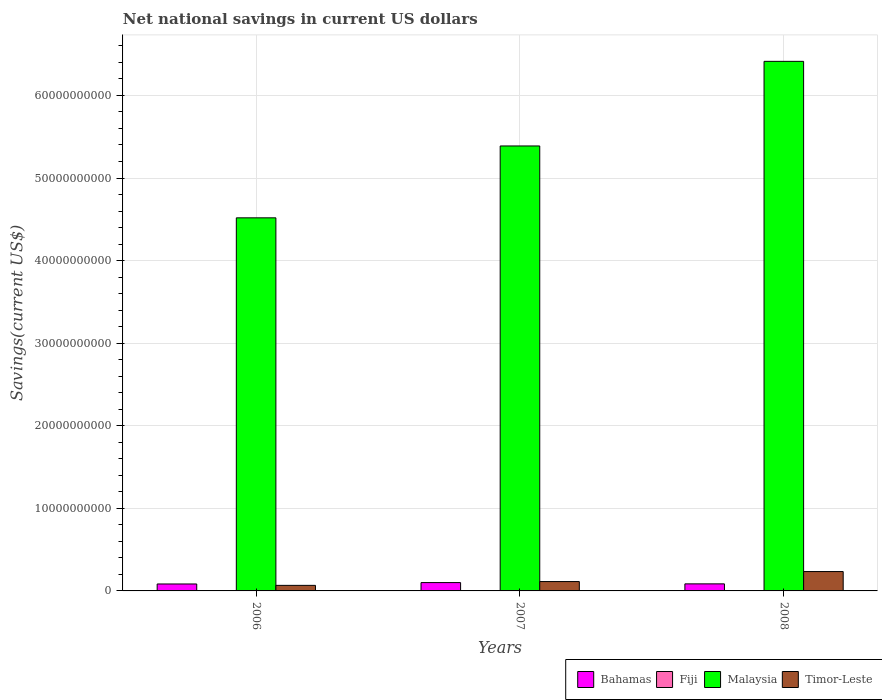How many different coloured bars are there?
Make the answer very short. 4. How many bars are there on the 2nd tick from the left?
Your answer should be very brief. 4. In how many cases, is the number of bars for a given year not equal to the number of legend labels?
Provide a succinct answer. 2. What is the net national savings in Bahamas in 2008?
Provide a short and direct response. 8.55e+08. Across all years, what is the maximum net national savings in Bahamas?
Provide a succinct answer. 1.01e+09. Across all years, what is the minimum net national savings in Timor-Leste?
Make the answer very short. 6.72e+08. What is the total net national savings in Bahamas in the graph?
Keep it short and to the point. 2.71e+09. What is the difference between the net national savings in Bahamas in 2006 and that in 2007?
Your response must be concise. -1.69e+08. What is the difference between the net national savings in Timor-Leste in 2007 and the net national savings in Malaysia in 2006?
Your answer should be very brief. -4.40e+1. What is the average net national savings in Timor-Leste per year?
Make the answer very short. 1.38e+09. In the year 2006, what is the difference between the net national savings in Timor-Leste and net national savings in Bahamas?
Offer a terse response. -1.70e+08. In how many years, is the net national savings in Bahamas greater than 24000000000 US$?
Offer a very short reply. 0. What is the ratio of the net national savings in Timor-Leste in 2006 to that in 2008?
Offer a very short reply. 0.29. Is the net national savings in Bahamas in 2006 less than that in 2007?
Ensure brevity in your answer.  Yes. What is the difference between the highest and the second highest net national savings in Timor-Leste?
Your answer should be very brief. 1.21e+09. What is the difference between the highest and the lowest net national savings in Bahamas?
Ensure brevity in your answer.  1.69e+08. Is the sum of the net national savings in Timor-Leste in 2006 and 2007 greater than the maximum net national savings in Malaysia across all years?
Offer a very short reply. No. Is it the case that in every year, the sum of the net national savings in Timor-Leste and net national savings in Malaysia is greater than the net national savings in Fiji?
Your answer should be compact. Yes. Are all the bars in the graph horizontal?
Keep it short and to the point. No. What is the difference between two consecutive major ticks on the Y-axis?
Offer a terse response. 1.00e+1. Are the values on the major ticks of Y-axis written in scientific E-notation?
Give a very brief answer. No. Where does the legend appear in the graph?
Your answer should be compact. Bottom right. What is the title of the graph?
Offer a terse response. Net national savings in current US dollars. What is the label or title of the Y-axis?
Give a very brief answer. Savings(current US$). What is the Savings(current US$) in Bahamas in 2006?
Make the answer very short. 8.41e+08. What is the Savings(current US$) in Malaysia in 2006?
Ensure brevity in your answer.  4.52e+1. What is the Savings(current US$) in Timor-Leste in 2006?
Your response must be concise. 6.72e+08. What is the Savings(current US$) in Bahamas in 2007?
Give a very brief answer. 1.01e+09. What is the Savings(current US$) of Fiji in 2007?
Make the answer very short. 1.97e+07. What is the Savings(current US$) of Malaysia in 2007?
Keep it short and to the point. 5.39e+1. What is the Savings(current US$) in Timor-Leste in 2007?
Give a very brief answer. 1.13e+09. What is the Savings(current US$) in Bahamas in 2008?
Offer a very short reply. 8.55e+08. What is the Savings(current US$) in Fiji in 2008?
Offer a terse response. 0. What is the Savings(current US$) of Malaysia in 2008?
Make the answer very short. 6.41e+1. What is the Savings(current US$) of Timor-Leste in 2008?
Provide a short and direct response. 2.35e+09. Across all years, what is the maximum Savings(current US$) of Bahamas?
Offer a terse response. 1.01e+09. Across all years, what is the maximum Savings(current US$) of Fiji?
Offer a terse response. 1.97e+07. Across all years, what is the maximum Savings(current US$) in Malaysia?
Keep it short and to the point. 6.41e+1. Across all years, what is the maximum Savings(current US$) of Timor-Leste?
Ensure brevity in your answer.  2.35e+09. Across all years, what is the minimum Savings(current US$) in Bahamas?
Provide a short and direct response. 8.41e+08. Across all years, what is the minimum Savings(current US$) in Malaysia?
Provide a succinct answer. 4.52e+1. Across all years, what is the minimum Savings(current US$) in Timor-Leste?
Provide a short and direct response. 6.72e+08. What is the total Savings(current US$) in Bahamas in the graph?
Ensure brevity in your answer.  2.71e+09. What is the total Savings(current US$) of Fiji in the graph?
Offer a terse response. 1.97e+07. What is the total Savings(current US$) in Malaysia in the graph?
Offer a very short reply. 1.63e+11. What is the total Savings(current US$) in Timor-Leste in the graph?
Provide a succinct answer. 4.15e+09. What is the difference between the Savings(current US$) in Bahamas in 2006 and that in 2007?
Your answer should be compact. -1.69e+08. What is the difference between the Savings(current US$) in Malaysia in 2006 and that in 2007?
Ensure brevity in your answer.  -8.70e+09. What is the difference between the Savings(current US$) in Timor-Leste in 2006 and that in 2007?
Offer a terse response. -4.62e+08. What is the difference between the Savings(current US$) in Bahamas in 2006 and that in 2008?
Offer a very short reply. -1.35e+07. What is the difference between the Savings(current US$) in Malaysia in 2006 and that in 2008?
Give a very brief answer. -1.89e+1. What is the difference between the Savings(current US$) of Timor-Leste in 2006 and that in 2008?
Provide a short and direct response. -1.67e+09. What is the difference between the Savings(current US$) of Bahamas in 2007 and that in 2008?
Your answer should be compact. 1.55e+08. What is the difference between the Savings(current US$) of Malaysia in 2007 and that in 2008?
Your answer should be compact. -1.02e+1. What is the difference between the Savings(current US$) of Timor-Leste in 2007 and that in 2008?
Your answer should be compact. -1.21e+09. What is the difference between the Savings(current US$) of Bahamas in 2006 and the Savings(current US$) of Fiji in 2007?
Keep it short and to the point. 8.22e+08. What is the difference between the Savings(current US$) in Bahamas in 2006 and the Savings(current US$) in Malaysia in 2007?
Offer a very short reply. -5.30e+1. What is the difference between the Savings(current US$) of Bahamas in 2006 and the Savings(current US$) of Timor-Leste in 2007?
Provide a succinct answer. -2.92e+08. What is the difference between the Savings(current US$) in Malaysia in 2006 and the Savings(current US$) in Timor-Leste in 2007?
Ensure brevity in your answer.  4.40e+1. What is the difference between the Savings(current US$) in Bahamas in 2006 and the Savings(current US$) in Malaysia in 2008?
Offer a very short reply. -6.33e+1. What is the difference between the Savings(current US$) of Bahamas in 2006 and the Savings(current US$) of Timor-Leste in 2008?
Offer a terse response. -1.50e+09. What is the difference between the Savings(current US$) in Malaysia in 2006 and the Savings(current US$) in Timor-Leste in 2008?
Make the answer very short. 4.28e+1. What is the difference between the Savings(current US$) of Bahamas in 2007 and the Savings(current US$) of Malaysia in 2008?
Provide a succinct answer. -6.31e+1. What is the difference between the Savings(current US$) of Bahamas in 2007 and the Savings(current US$) of Timor-Leste in 2008?
Make the answer very short. -1.34e+09. What is the difference between the Savings(current US$) of Fiji in 2007 and the Savings(current US$) of Malaysia in 2008?
Offer a terse response. -6.41e+1. What is the difference between the Savings(current US$) in Fiji in 2007 and the Savings(current US$) in Timor-Leste in 2008?
Your answer should be compact. -2.33e+09. What is the difference between the Savings(current US$) of Malaysia in 2007 and the Savings(current US$) of Timor-Leste in 2008?
Ensure brevity in your answer.  5.15e+1. What is the average Savings(current US$) in Bahamas per year?
Give a very brief answer. 9.02e+08. What is the average Savings(current US$) of Fiji per year?
Provide a succinct answer. 6.57e+06. What is the average Savings(current US$) of Malaysia per year?
Your response must be concise. 5.44e+1. What is the average Savings(current US$) in Timor-Leste per year?
Your answer should be very brief. 1.38e+09. In the year 2006, what is the difference between the Savings(current US$) in Bahamas and Savings(current US$) in Malaysia?
Offer a very short reply. -4.43e+1. In the year 2006, what is the difference between the Savings(current US$) in Bahamas and Savings(current US$) in Timor-Leste?
Your response must be concise. 1.70e+08. In the year 2006, what is the difference between the Savings(current US$) of Malaysia and Savings(current US$) of Timor-Leste?
Provide a succinct answer. 4.45e+1. In the year 2007, what is the difference between the Savings(current US$) of Bahamas and Savings(current US$) of Fiji?
Give a very brief answer. 9.91e+08. In the year 2007, what is the difference between the Savings(current US$) of Bahamas and Savings(current US$) of Malaysia?
Make the answer very short. -5.29e+1. In the year 2007, what is the difference between the Savings(current US$) of Bahamas and Savings(current US$) of Timor-Leste?
Offer a very short reply. -1.23e+08. In the year 2007, what is the difference between the Savings(current US$) in Fiji and Savings(current US$) in Malaysia?
Your answer should be compact. -5.39e+1. In the year 2007, what is the difference between the Savings(current US$) in Fiji and Savings(current US$) in Timor-Leste?
Keep it short and to the point. -1.11e+09. In the year 2007, what is the difference between the Savings(current US$) of Malaysia and Savings(current US$) of Timor-Leste?
Provide a succinct answer. 5.27e+1. In the year 2008, what is the difference between the Savings(current US$) of Bahamas and Savings(current US$) of Malaysia?
Keep it short and to the point. -6.33e+1. In the year 2008, what is the difference between the Savings(current US$) of Bahamas and Savings(current US$) of Timor-Leste?
Make the answer very short. -1.49e+09. In the year 2008, what is the difference between the Savings(current US$) of Malaysia and Savings(current US$) of Timor-Leste?
Your answer should be very brief. 6.18e+1. What is the ratio of the Savings(current US$) of Bahamas in 2006 to that in 2007?
Offer a terse response. 0.83. What is the ratio of the Savings(current US$) in Malaysia in 2006 to that in 2007?
Your answer should be very brief. 0.84. What is the ratio of the Savings(current US$) in Timor-Leste in 2006 to that in 2007?
Provide a succinct answer. 0.59. What is the ratio of the Savings(current US$) in Bahamas in 2006 to that in 2008?
Ensure brevity in your answer.  0.98. What is the ratio of the Savings(current US$) in Malaysia in 2006 to that in 2008?
Offer a terse response. 0.7. What is the ratio of the Savings(current US$) in Timor-Leste in 2006 to that in 2008?
Provide a succinct answer. 0.29. What is the ratio of the Savings(current US$) of Bahamas in 2007 to that in 2008?
Provide a short and direct response. 1.18. What is the ratio of the Savings(current US$) of Malaysia in 2007 to that in 2008?
Give a very brief answer. 0.84. What is the ratio of the Savings(current US$) in Timor-Leste in 2007 to that in 2008?
Your answer should be compact. 0.48. What is the difference between the highest and the second highest Savings(current US$) of Bahamas?
Give a very brief answer. 1.55e+08. What is the difference between the highest and the second highest Savings(current US$) in Malaysia?
Your answer should be very brief. 1.02e+1. What is the difference between the highest and the second highest Savings(current US$) of Timor-Leste?
Give a very brief answer. 1.21e+09. What is the difference between the highest and the lowest Savings(current US$) of Bahamas?
Keep it short and to the point. 1.69e+08. What is the difference between the highest and the lowest Savings(current US$) of Fiji?
Ensure brevity in your answer.  1.97e+07. What is the difference between the highest and the lowest Savings(current US$) in Malaysia?
Make the answer very short. 1.89e+1. What is the difference between the highest and the lowest Savings(current US$) in Timor-Leste?
Keep it short and to the point. 1.67e+09. 